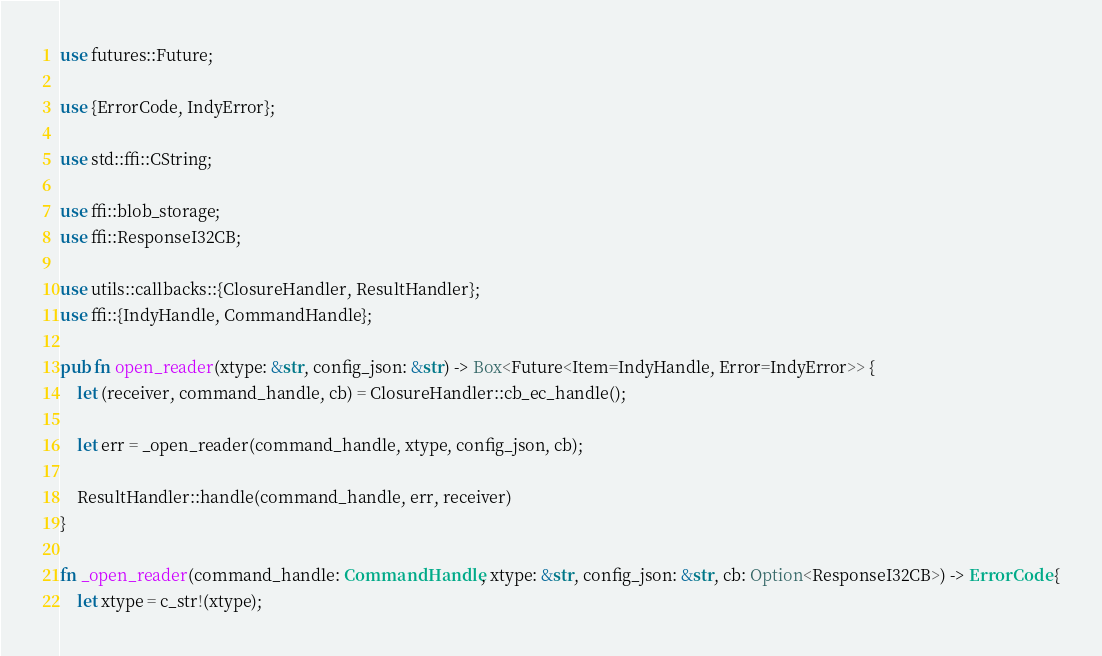Convert code to text. <code><loc_0><loc_0><loc_500><loc_500><_Rust_>use futures::Future;

use {ErrorCode, IndyError};

use std::ffi::CString;

use ffi::blob_storage;
use ffi::ResponseI32CB;

use utils::callbacks::{ClosureHandler, ResultHandler};
use ffi::{IndyHandle, CommandHandle};

pub fn open_reader(xtype: &str, config_json: &str) -> Box<Future<Item=IndyHandle, Error=IndyError>> {
    let (receiver, command_handle, cb) = ClosureHandler::cb_ec_handle();

    let err = _open_reader(command_handle, xtype, config_json, cb);

    ResultHandler::handle(command_handle, err, receiver)
}

fn _open_reader(command_handle: CommandHandle, xtype: &str, config_json: &str, cb: Option<ResponseI32CB>) -> ErrorCode {
    let xtype = c_str!(xtype);</code> 